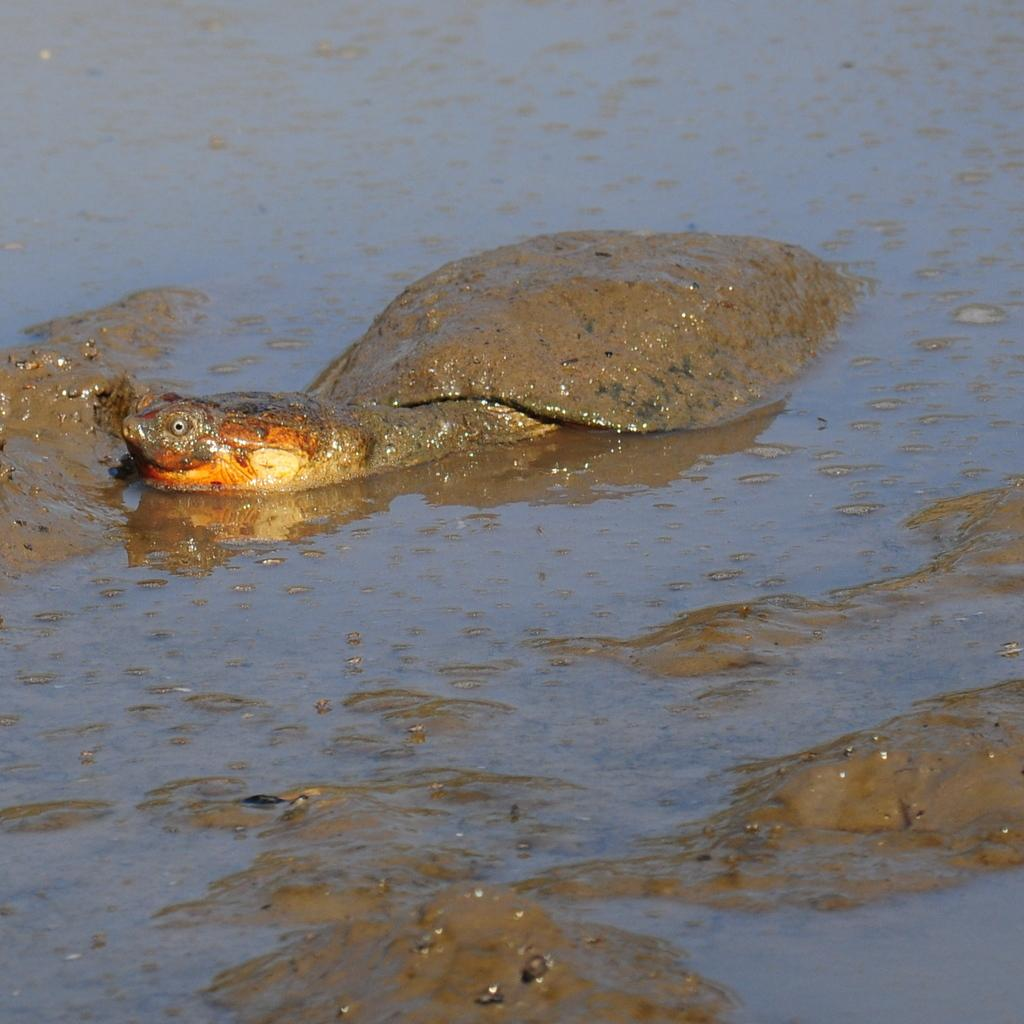What animal is present in the image? There is a tortoise in the image. Where is the tortoise located? The tortoise is in the water. What is the tortoise near in the image? The tortoise is near wet mud. What type of wire is being used to hold the tortoise's attention in the image? There is no wire present in the image, and the tortoise's attention is not being held by any object. 